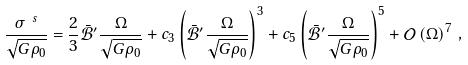Convert formula to latex. <formula><loc_0><loc_0><loc_500><loc_500>\frac { \sigma ^ { \ s } } { \sqrt { G \rho _ { 0 } } } = \frac { 2 } { 3 } \mathcal { \bar { B } ^ { \prime } } \frac { \Omega } { \sqrt { G \rho _ { 0 } } } + c _ { 3 } \left ( \mathcal { \bar { B } ^ { \prime } } \frac { \Omega } { \sqrt { G \rho _ { 0 } } } \right ) ^ { 3 } + c _ { 5 } \left ( \mathcal { \bar { B } ^ { \prime } } \frac { \Omega } { \sqrt { G \rho _ { 0 } } } \right ) ^ { 5 } + \mathcal { O } \left ( \Omega \right ) ^ { 7 } \, ,</formula> 